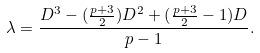Convert formula to latex. <formula><loc_0><loc_0><loc_500><loc_500>\lambda = \frac { D ^ { 3 } - ( \frac { p + 3 } { 2 } ) D ^ { 2 } + ( \frac { p + 3 } { 2 } - 1 ) D } { p - 1 } .</formula> 